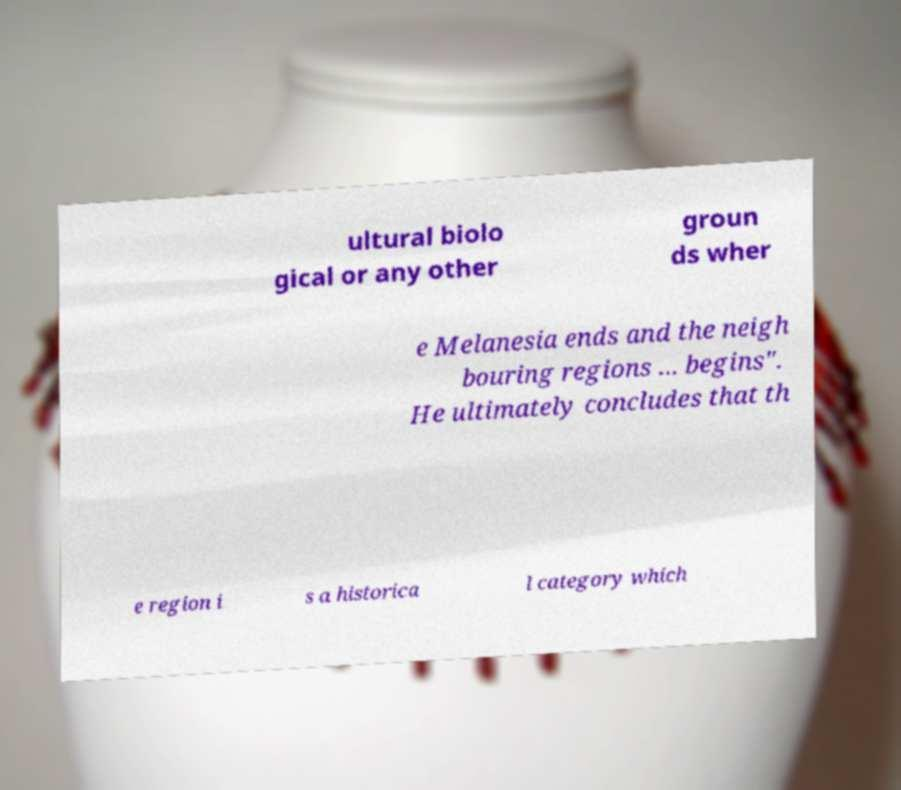What messages or text are displayed in this image? I need them in a readable, typed format. ultural biolo gical or any other groun ds wher e Melanesia ends and the neigh bouring regions ... begins". He ultimately concludes that th e region i s a historica l category which 